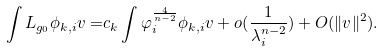Convert formula to latex. <formula><loc_0><loc_0><loc_500><loc_500>\int L _ { g _ { 0 } } \phi _ { k , i } v = & c _ { k } \int \varphi _ { i } ^ { \frac { 4 } { n - 2 } } \phi _ { k , i } v + o ( \frac { 1 } { \lambda _ { i } ^ { n - 2 } } ) + O ( \| v \| ^ { 2 } ) .</formula> 